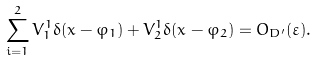Convert formula to latex. <formula><loc_0><loc_0><loc_500><loc_500>\sum ^ { 2 } _ { i = 1 } V ^ { 1 } _ { 1 } \delta ( x - \varphi _ { 1 } ) + V ^ { 1 } _ { 2 } \delta ( x - \varphi _ { 2 } ) = O _ { D ^ { \prime } } ( \varepsilon ) .</formula> 